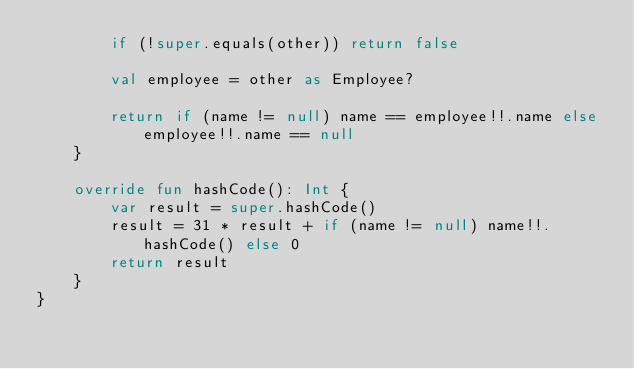Convert code to text. <code><loc_0><loc_0><loc_500><loc_500><_Kotlin_>        if (!super.equals(other)) return false

        val employee = other as Employee?

        return if (name != null) name == employee!!.name else employee!!.name == null
    }

    override fun hashCode(): Int {
        var result = super.hashCode()
        result = 31 * result + if (name != null) name!!.hashCode() else 0
        return result
    }
}</code> 